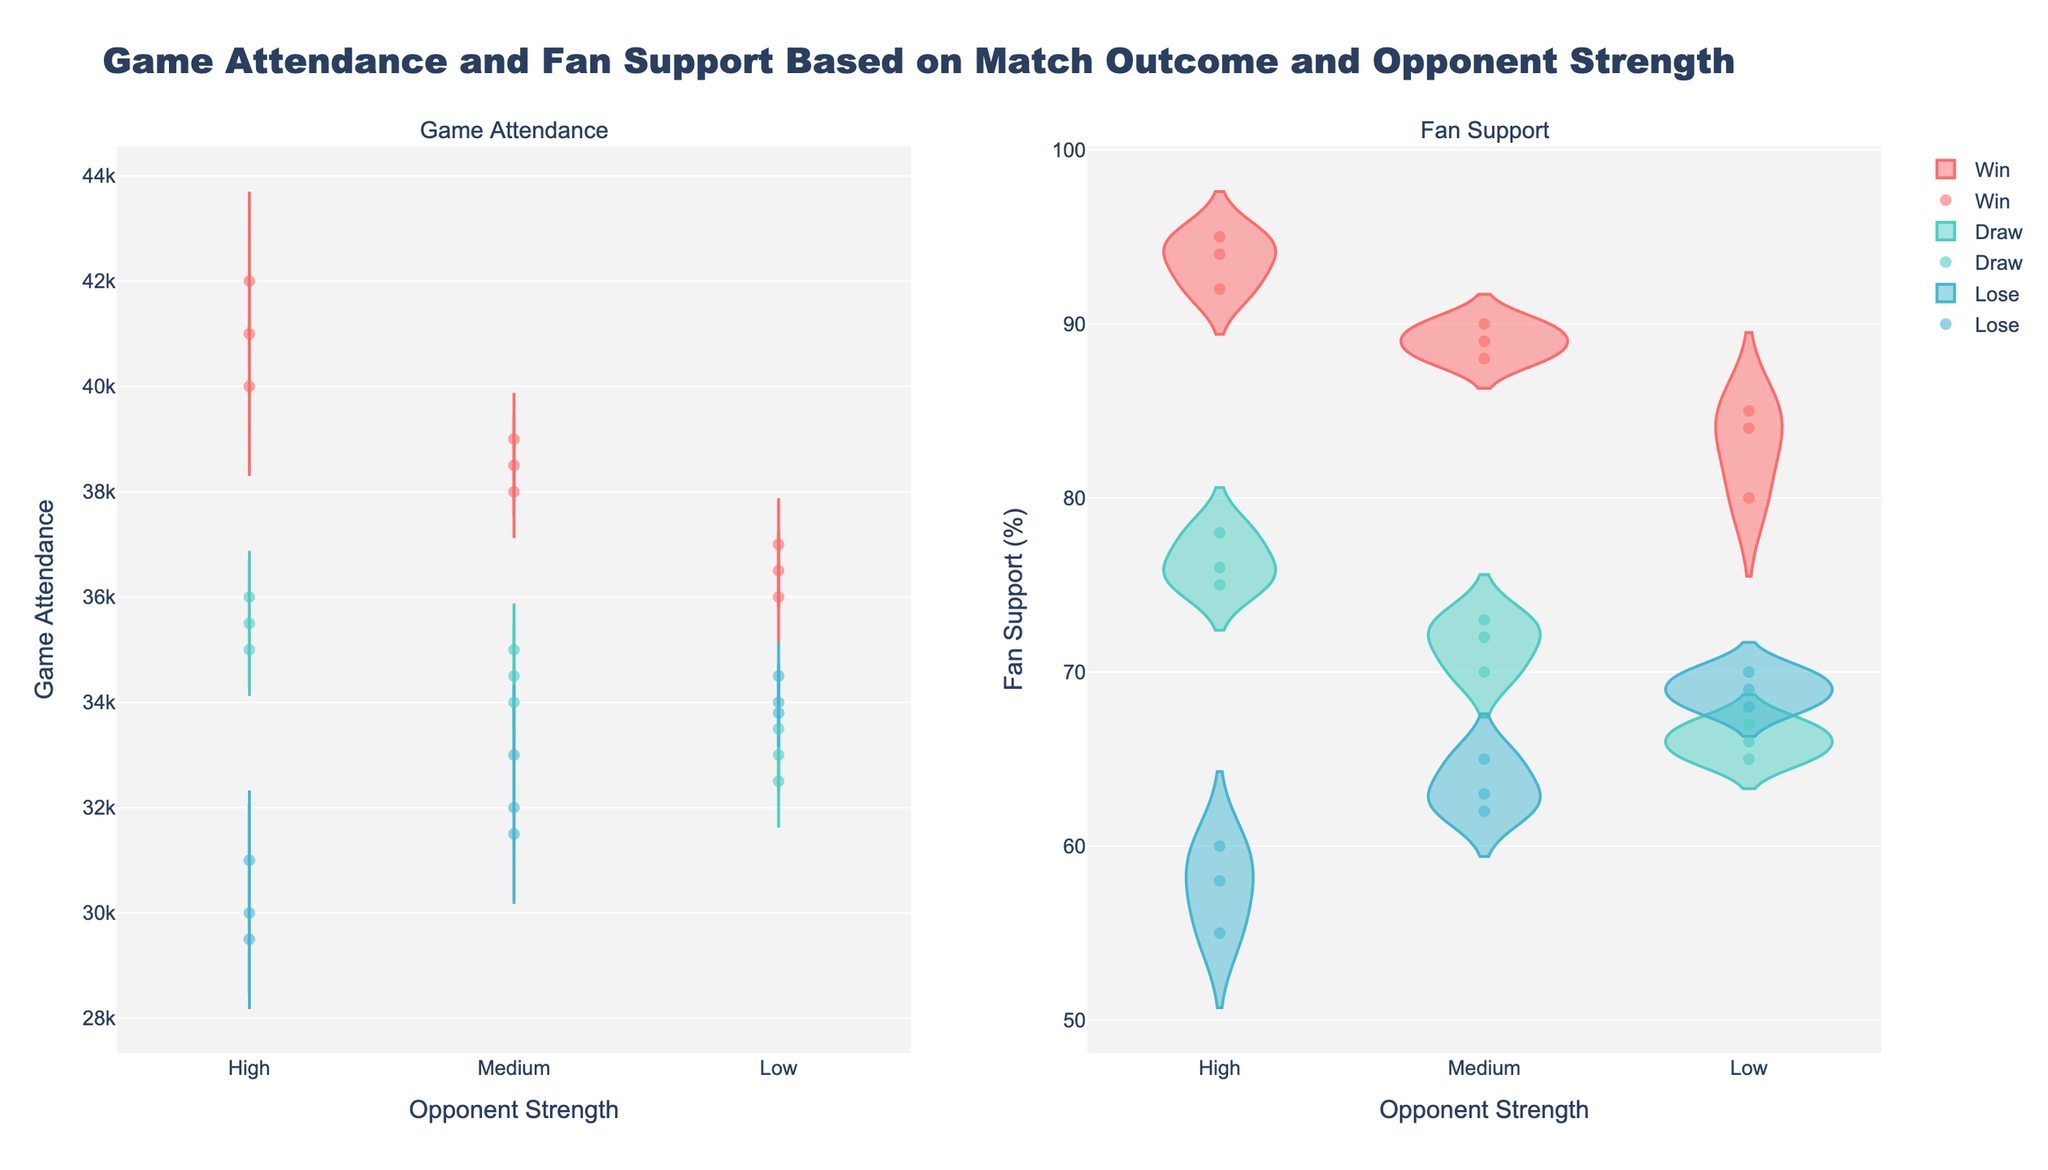What's the main title of the figure? The main title of the figure is shown at the top. It indicates the overall topic of the visualization.
Answer: Game Attendance and Fan Support Based on Match Outcome and Opponent Strength What are the y-axis titles on the left and right subplots? The y-axis titles can be found on the vertical lines of the subplots; they describe what is being measured. The left subplot measures "Game Attendance" and the right subplot measures "Fan Support (%)".
Answer: Game Attendance, Fan Support (%) Which match outcome has the highest game attendance against high strength opponents? To answer this, we need to look at the distribution on the left violin plot for "High" strength opponent. Observing the spread, the "Win" outcome has the highest game attendance values.
Answer: Win Does fan support tend to be higher when the match result is a win compared to a loss? To answer this, compare the distributions in the right violin plot for "Win" and "Lose". The "Win" outcome has a distribution generally positioned higher than the "Lose" outcome, indicating higher fan support for wins.
Answer: Yes What is the general trend in game attendance when comparing different opponent strengths for a match loss? Examine the left violin plot within the "Lose" sections. Note how the distribution of game attendance changes from "High" to "Low" opponent strength. Game attendance tends to increase as opponent strength decreases.
Answer: Increases How does the variation in fan support compare between wins and draws against high strength opponents? Observe the right violin plot and look at the spread of fan support for "Win" and "Draw" outcomes against "High" opponents. The distribution for wins has a wider spread and generally higher values, while draws have a narrower spread.
Answer: Wins have more variation and higher values What is the average game attendance for matches with medium opponent strength when the match outcome is a loss? First, locate the violin plot for "Lose" and "Medium" strength opponents in the left subplot. Then, estimate the central tendency (average) within that distribution by observing the position of the bulk of the data points. The average appears to be around 32,500.
Answer: Around 32,500 Which match outcome seems to have the least impact on game attendance regardless of opponent strength? Compare the length and spread of the violins on the left subplot. The "Draw" outcome has distributions that are more consistent and less extreme across different opponent strengths compared to "Win" or "Lose".
Answer: Draw 